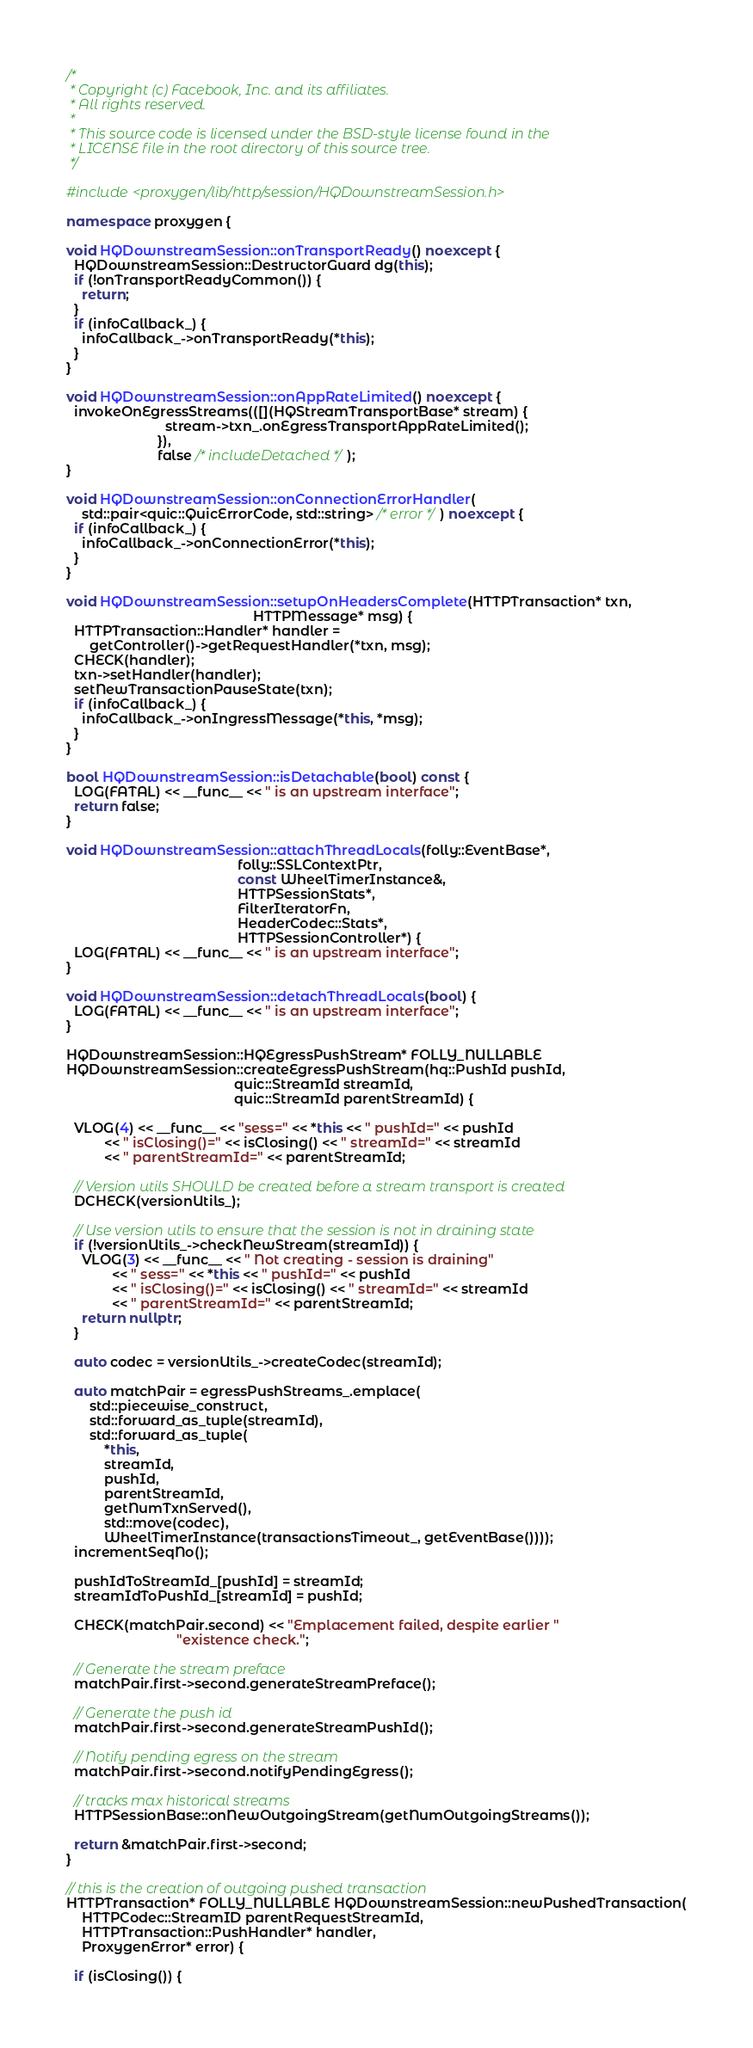<code> <loc_0><loc_0><loc_500><loc_500><_C++_>/*
 * Copyright (c) Facebook, Inc. and its affiliates.
 * All rights reserved.
 *
 * This source code is licensed under the BSD-style license found in the
 * LICENSE file in the root directory of this source tree.
 */

#include <proxygen/lib/http/session/HQDownstreamSession.h>

namespace proxygen {

void HQDownstreamSession::onTransportReady() noexcept {
  HQDownstreamSession::DestructorGuard dg(this);
  if (!onTransportReadyCommon()) {
    return;
  }
  if (infoCallback_) {
    infoCallback_->onTransportReady(*this);
  }
}

void HQDownstreamSession::onAppRateLimited() noexcept {
  invokeOnEgressStreams(([](HQStreamTransportBase* stream) {
                          stream->txn_.onEgressTransportAppRateLimited();
                        }),
                        false /* includeDetached */);
}

void HQDownstreamSession::onConnectionErrorHandler(
    std::pair<quic::QuicErrorCode, std::string> /* error */) noexcept {
  if (infoCallback_) {
    infoCallback_->onConnectionError(*this);
  }
}

void HQDownstreamSession::setupOnHeadersComplete(HTTPTransaction* txn,
                                                 HTTPMessage* msg) {
  HTTPTransaction::Handler* handler =
      getController()->getRequestHandler(*txn, msg);
  CHECK(handler);
  txn->setHandler(handler);
  setNewTransactionPauseState(txn);
  if (infoCallback_) {
    infoCallback_->onIngressMessage(*this, *msg);
  }
}

bool HQDownstreamSession::isDetachable(bool) const {
  LOG(FATAL) << __func__ << " is an upstream interface";
  return false;
}

void HQDownstreamSession::attachThreadLocals(folly::EventBase*,
                                             folly::SSLContextPtr,
                                             const WheelTimerInstance&,
                                             HTTPSessionStats*,
                                             FilterIteratorFn,
                                             HeaderCodec::Stats*,
                                             HTTPSessionController*) {
  LOG(FATAL) << __func__ << " is an upstream interface";
}

void HQDownstreamSession::detachThreadLocals(bool) {
  LOG(FATAL) << __func__ << " is an upstream interface";
}

HQDownstreamSession::HQEgressPushStream* FOLLY_NULLABLE
HQDownstreamSession::createEgressPushStream(hq::PushId pushId,
                                            quic::StreamId streamId,
                                            quic::StreamId parentStreamId) {

  VLOG(4) << __func__ << "sess=" << *this << " pushId=" << pushId
          << " isClosing()=" << isClosing() << " streamId=" << streamId
          << " parentStreamId=" << parentStreamId;

  // Version utils SHOULD be created before a stream transport is created
  DCHECK(versionUtils_);

  // Use version utils to ensure that the session is not in draining state
  if (!versionUtils_->checkNewStream(streamId)) {
    VLOG(3) << __func__ << " Not creating - session is draining"
            << " sess=" << *this << " pushId=" << pushId
            << " isClosing()=" << isClosing() << " streamId=" << streamId
            << " parentStreamId=" << parentStreamId;
    return nullptr;
  }

  auto codec = versionUtils_->createCodec(streamId);

  auto matchPair = egressPushStreams_.emplace(
      std::piecewise_construct,
      std::forward_as_tuple(streamId),
      std::forward_as_tuple(
          *this,
          streamId,
          pushId,
          parentStreamId,
          getNumTxnServed(),
          std::move(codec),
          WheelTimerInstance(transactionsTimeout_, getEventBase())));
  incrementSeqNo();

  pushIdToStreamId_[pushId] = streamId;
  streamIdToPushId_[streamId] = pushId;

  CHECK(matchPair.second) << "Emplacement failed, despite earlier "
                             "existence check.";

  // Generate the stream preface
  matchPair.first->second.generateStreamPreface();

  // Generate the push id
  matchPair.first->second.generateStreamPushId();

  // Notify pending egress on the stream
  matchPair.first->second.notifyPendingEgress();

  // tracks max historical streams
  HTTPSessionBase::onNewOutgoingStream(getNumOutgoingStreams());

  return &matchPair.first->second;
}

// this is the creation of outgoing pushed transaction
HTTPTransaction* FOLLY_NULLABLE HQDownstreamSession::newPushedTransaction(
    HTTPCodec::StreamID parentRequestStreamId,
    HTTPTransaction::PushHandler* handler,
    ProxygenError* error) {

  if (isClosing()) {</code> 